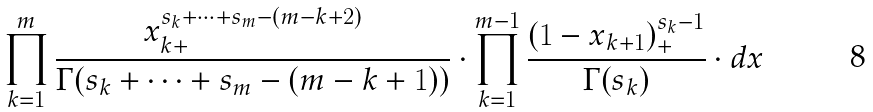Convert formula to latex. <formula><loc_0><loc_0><loc_500><loc_500>\prod _ { k = 1 } ^ { m } \frac { x _ { k + } ^ { s _ { k } + \dots + s _ { m } - ( m - k + 2 ) } } { \Gamma ( s _ { k } + \dots + s _ { m } - ( m - k + 1 ) ) } \cdot \prod _ { k = 1 } ^ { m - 1 } \frac { ( 1 - x _ { k + 1 } ) _ { + } ^ { s _ { k } - 1 } } { \Gamma ( s _ { k } ) } \cdot d x</formula> 